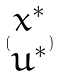Convert formula to latex. <formula><loc_0><loc_0><loc_500><loc_500>( \begin{matrix} x ^ { * } \\ u ^ { * } \end{matrix} )</formula> 